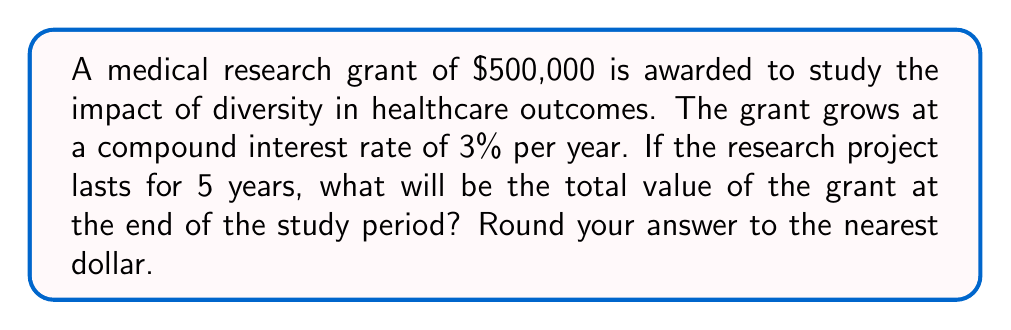Can you answer this question? Let's approach this step-by-step using the compound interest formula:

1) The compound interest formula is:
   $A = P(1 + r)^t$
   Where:
   $A$ = final amount
   $P$ = principal (initial investment)
   $r$ = annual interest rate (in decimal form)
   $t$ = time in years

2) We know:
   $P = \$500,000$
   $r = 3\% = 0.03$
   $t = 5$ years

3) Let's substitute these values into the formula:
   $A = 500,000(1 + 0.03)^5$

4) Calculate the value inside the parentheses:
   $A = 500,000(1.03)^5$

5) Use a calculator to compute $(1.03)^5$:
   $(1.03)^5 \approx 1.159274$

6) Multiply this by the principal:
   $A = 500,000 \times 1.159274 = 579,637$

7) Rounding to the nearest dollar:
   $A = \$579,637$
Answer: $579,637 